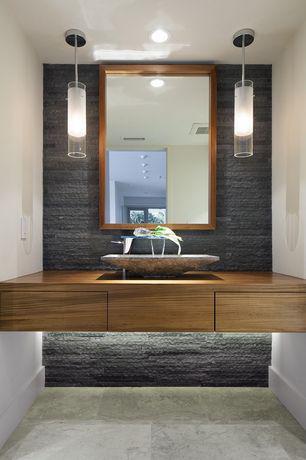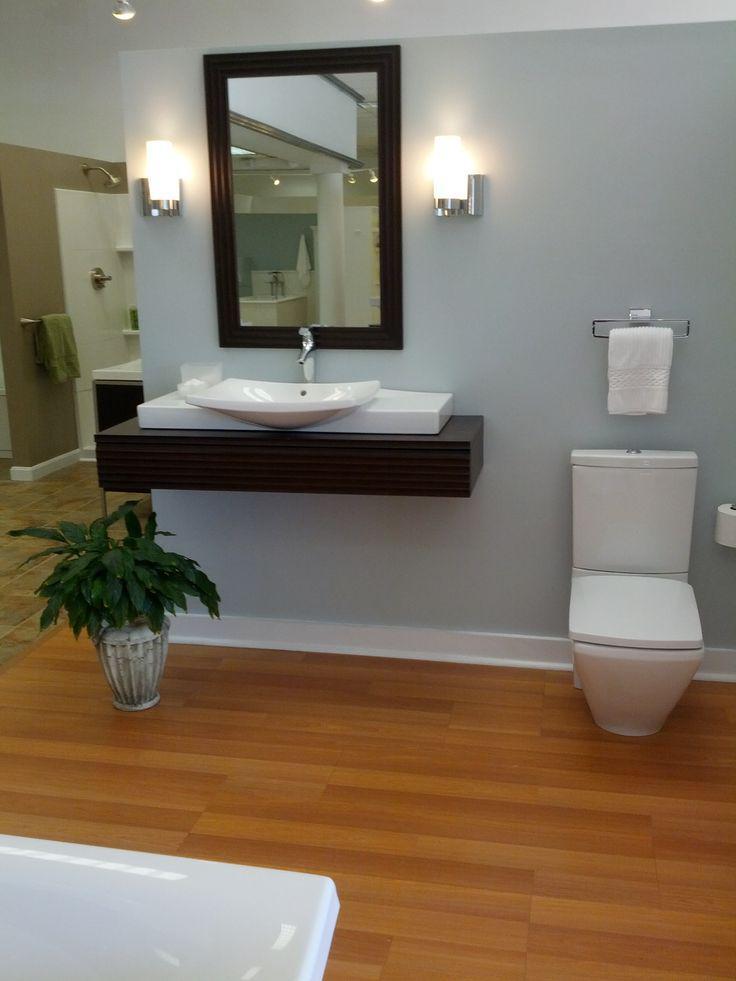The first image is the image on the left, the second image is the image on the right. For the images displayed, is the sentence "One of the sinks has no drawers attached to it." factually correct? Answer yes or no. Yes. The first image is the image on the left, the second image is the image on the right. Considering the images on both sides, is "Both image show a sink and vanity, but only one image has a rectangular sink basin." valid? Answer yes or no. No. 